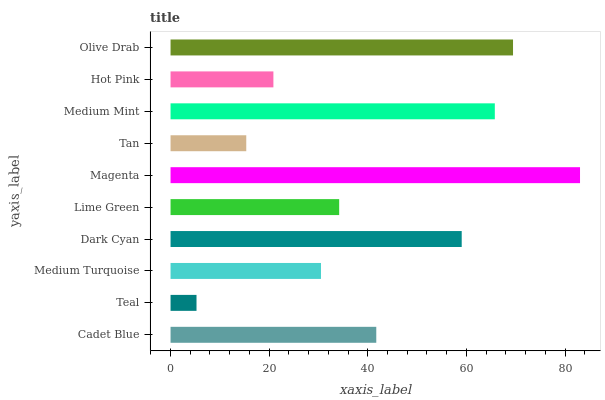Is Teal the minimum?
Answer yes or no. Yes. Is Magenta the maximum?
Answer yes or no. Yes. Is Medium Turquoise the minimum?
Answer yes or no. No. Is Medium Turquoise the maximum?
Answer yes or no. No. Is Medium Turquoise greater than Teal?
Answer yes or no. Yes. Is Teal less than Medium Turquoise?
Answer yes or no. Yes. Is Teal greater than Medium Turquoise?
Answer yes or no. No. Is Medium Turquoise less than Teal?
Answer yes or no. No. Is Cadet Blue the high median?
Answer yes or no. Yes. Is Lime Green the low median?
Answer yes or no. Yes. Is Dark Cyan the high median?
Answer yes or no. No. Is Magenta the low median?
Answer yes or no. No. 